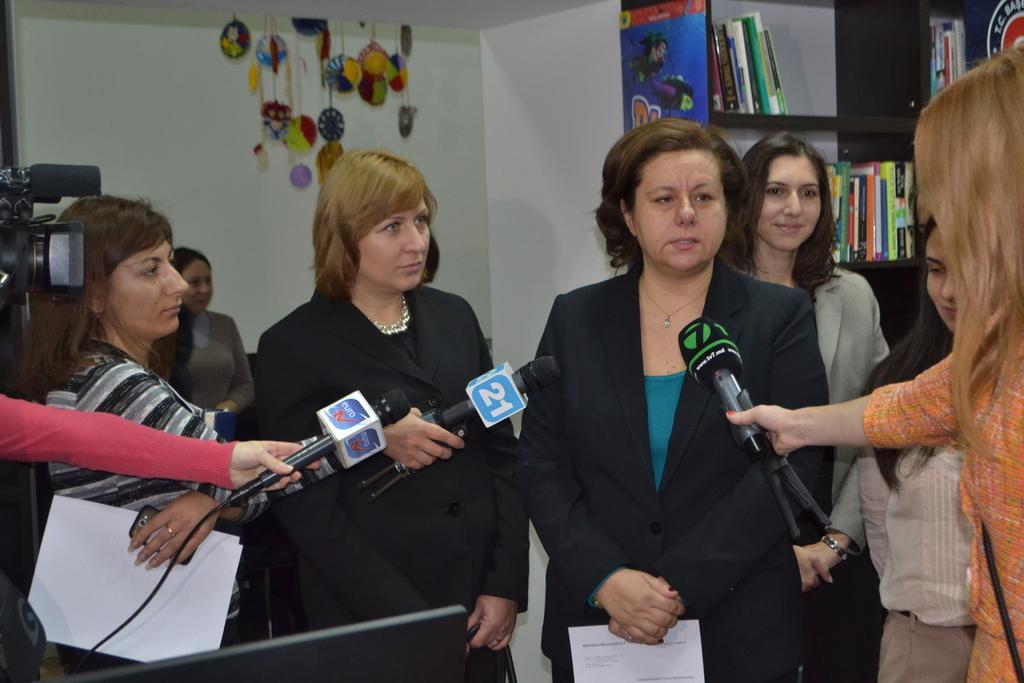Can you describe this image briefly? In this picture there are four persons standing and there are few persons holding mics in their hand are standing in front of them and there is a camera in the left corner and there is a book shelf in the right top corner. 